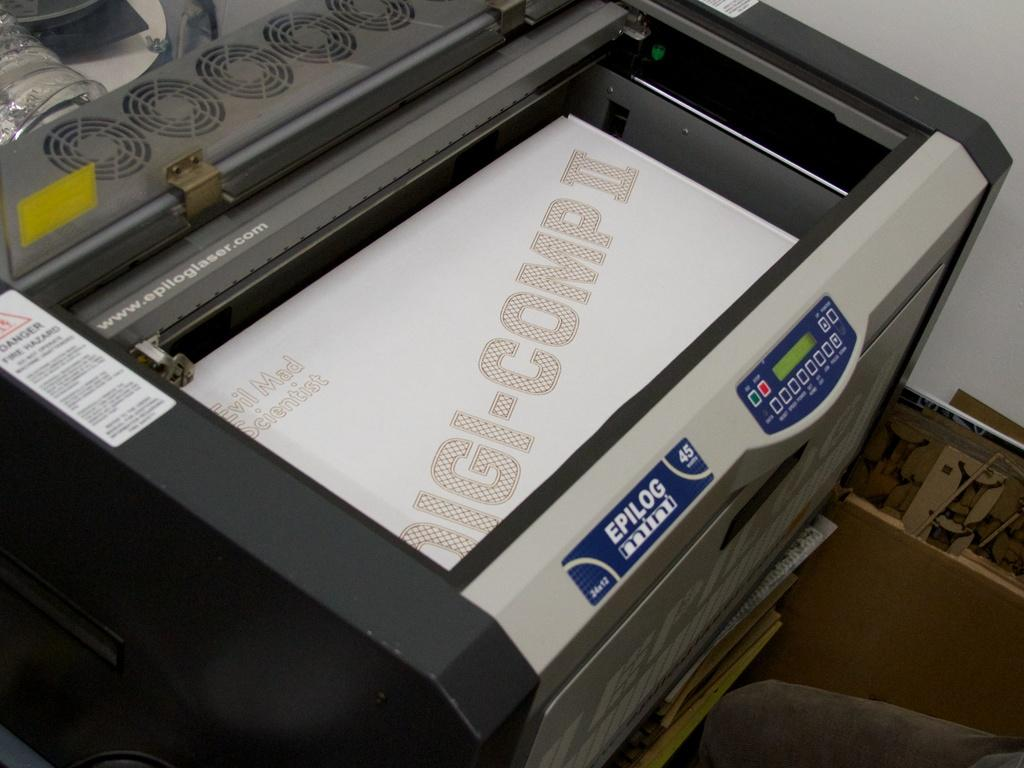What is the main object in the image? There is a xerox machine in the image. Where is the xerox machine located? The xerox machine is in a room. What can be seen beneath the xerox machine? There is a floor visible in the image. What is to the right of the xerox machine? There is a wall to the right in the image. What flavor of ice cream is being xeroxed in the image? There is no ice cream present in the image, and the xerox machine is not being used to xerox ice cream. 